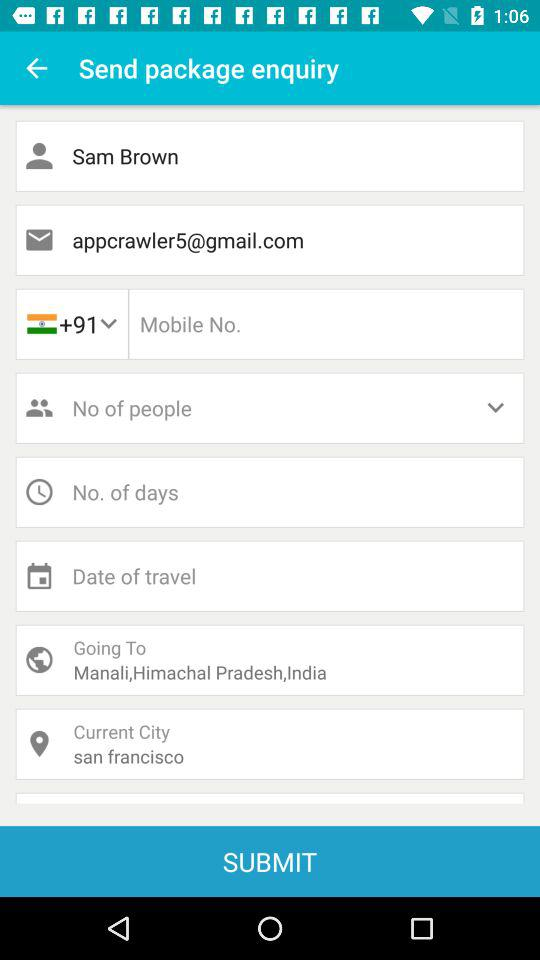What is the country code? The country code is +91. 